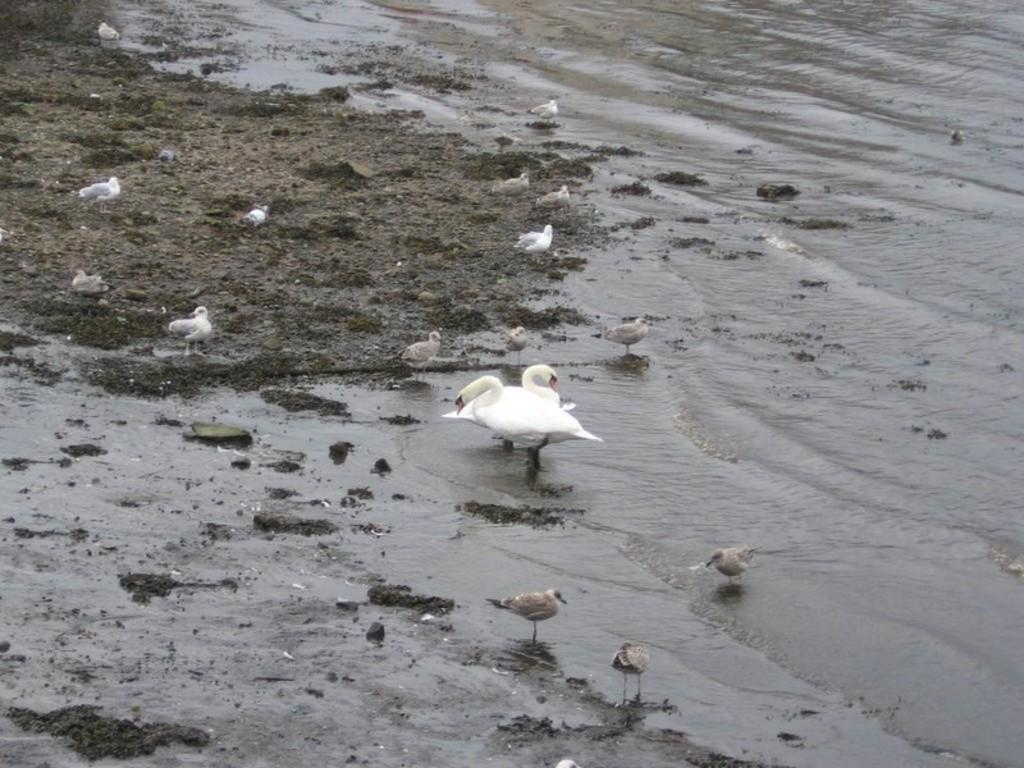What is present in the image that is not solid? There is water visible in the image. What type of animals can be seen in the image? Birds can be seen in the image. Where is the fork placed in the image? There is no fork present in the image. What type of throne can be seen in the image? There is no throne present in the image. 